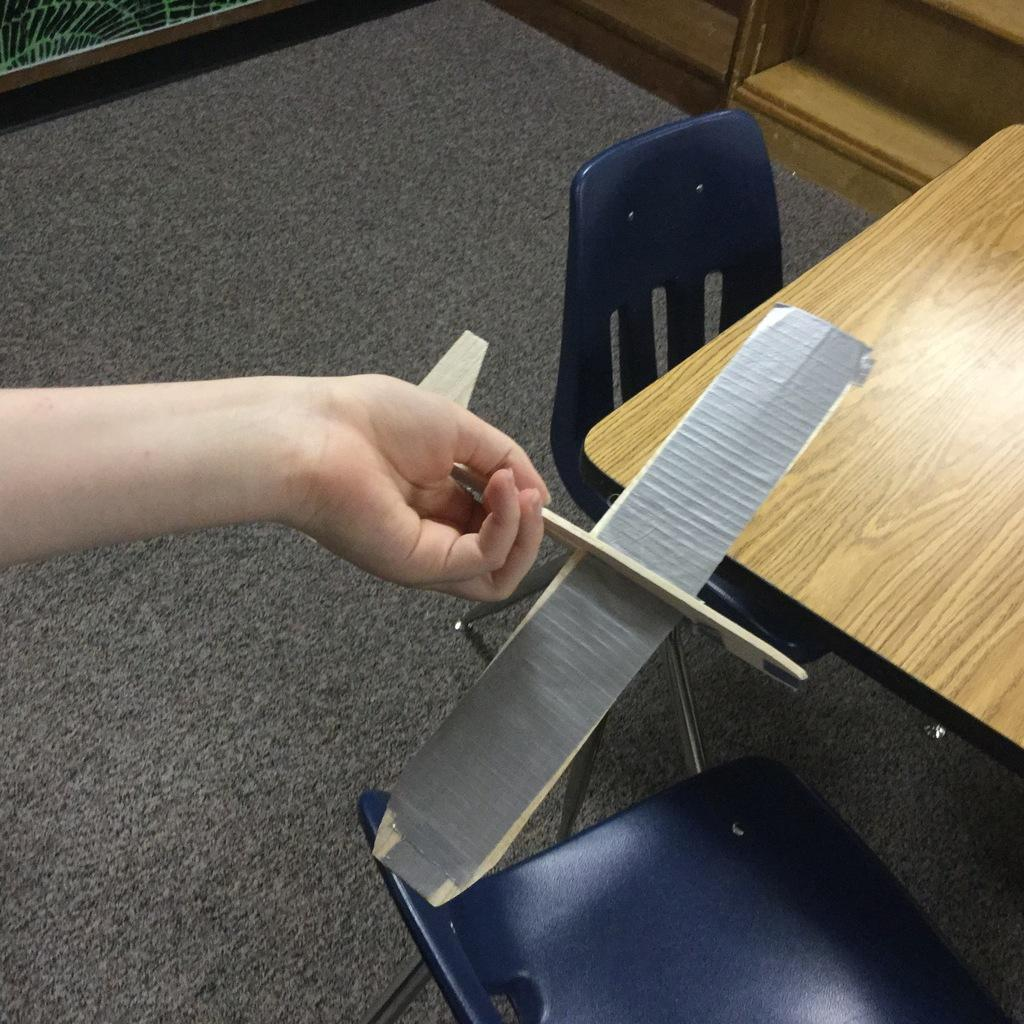What part of a person can be seen in the image? A person's hand is visible in the image. What is the person holding in the image? The person is holding an object. What type of furniture is on the floor in the image? There are chairs on the floor. What is in front of the chairs in the image? There is a table in front of the chairs. Where is the rack located in the image? There is a rack in the top right corner of the image. What type of leather is visible in the field in the image? There is no leather or field present in the image. How does the person navigate through the quicksand in the image? There is no quicksand present in the image; the person is holding an object while standing on a floor with chairs and a table. 